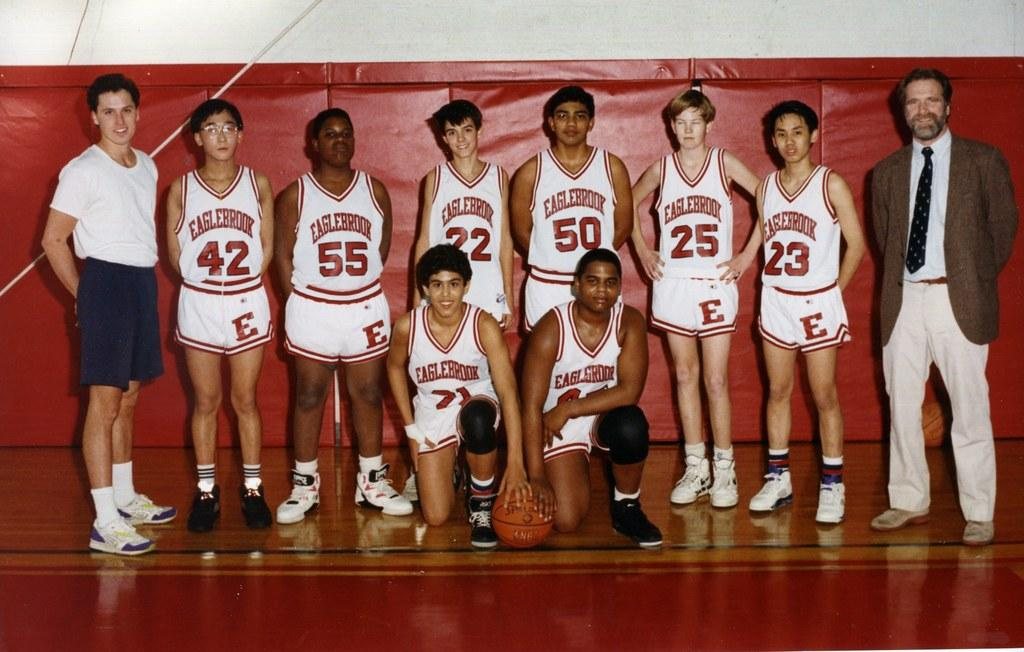<image>
Present a compact description of the photo's key features. A basketball team wearing Eaglebrook jerseys poses for a picture. 